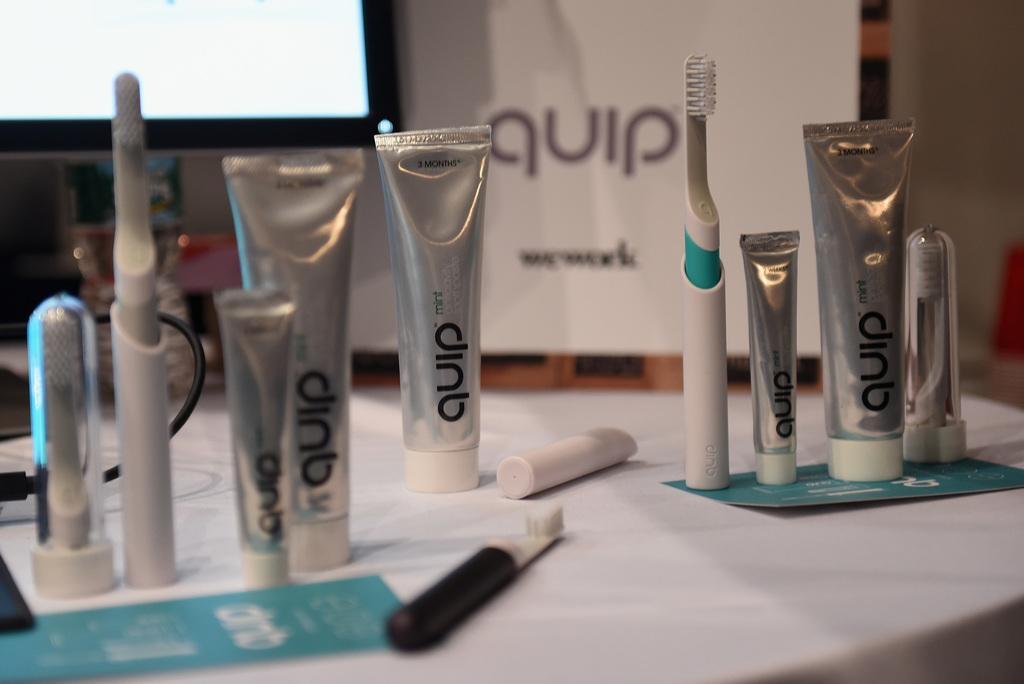Can you describe this image briefly? In this picture we can observe some toothpastes on the white color table. In the background we can observe a screen. 